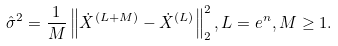Convert formula to latex. <formula><loc_0><loc_0><loc_500><loc_500>\hat { \sigma } ^ { 2 } = \frac { 1 } { M } \left \| \dot { X } ^ { ( L + M ) } - \dot { X } ^ { ( L ) } \right \| _ { 2 } ^ { 2 } , L = e ^ { n } , M \geq 1 .</formula> 